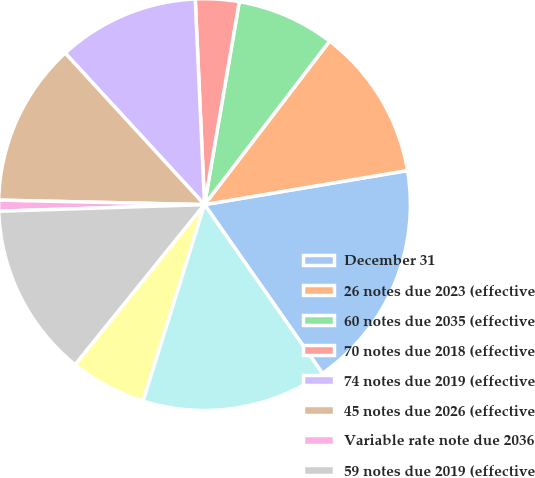<chart> <loc_0><loc_0><loc_500><loc_500><pie_chart><fcel>December 31<fcel>26 notes due 2023 (effective<fcel>60 notes due 2035 (effective<fcel>70 notes due 2018 (effective<fcel>74 notes due 2019 (effective<fcel>45 notes due 2026 (effective<fcel>Variable rate note due 2036<fcel>59 notes due 2019 (effective<fcel>35 notes due 2023 (effective<fcel>57 notes due 2039 (effective<nl><fcel>17.94%<fcel>11.96%<fcel>7.69%<fcel>3.42%<fcel>11.11%<fcel>12.82%<fcel>0.86%<fcel>13.67%<fcel>5.99%<fcel>14.53%<nl></chart> 